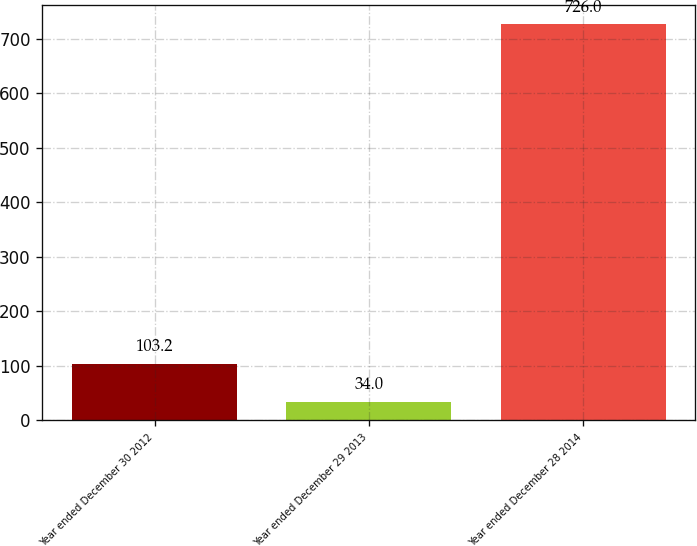Convert chart to OTSL. <chart><loc_0><loc_0><loc_500><loc_500><bar_chart><fcel>Year ended December 30 2012<fcel>Year ended December 29 2013<fcel>Year ended December 28 2014<nl><fcel>103.2<fcel>34<fcel>726<nl></chart> 